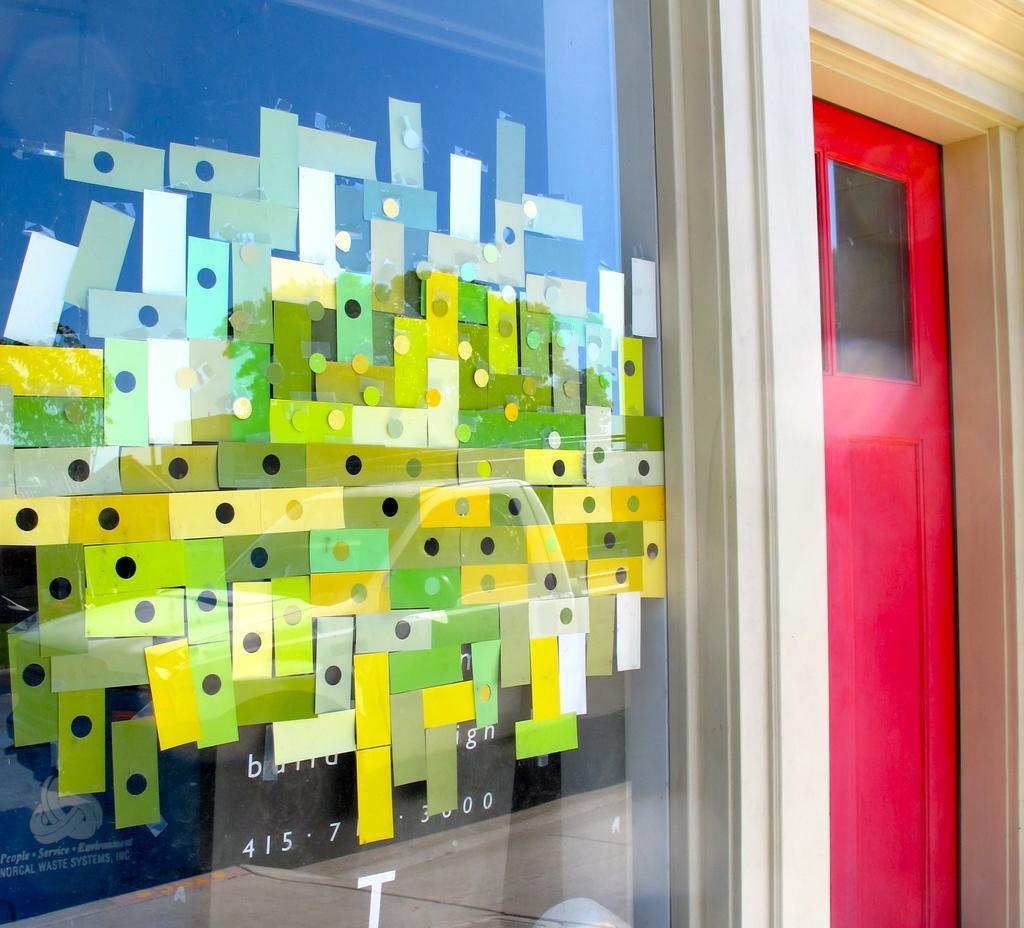Please provide a concise description of this image. In this image there is a wall and we can see a board. On the right there is a door. 